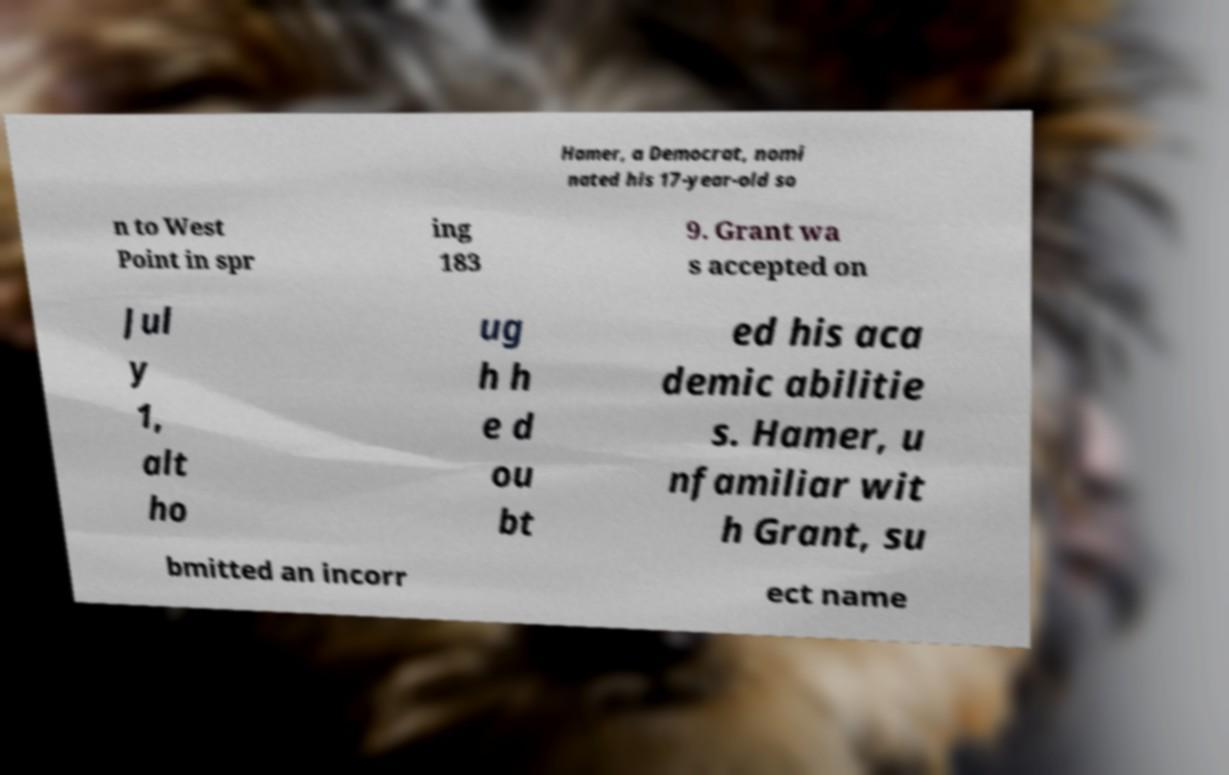Can you read and provide the text displayed in the image?This photo seems to have some interesting text. Can you extract and type it out for me? Hamer, a Democrat, nomi nated his 17-year-old so n to West Point in spr ing 183 9. Grant wa s accepted on Jul y 1, alt ho ug h h e d ou bt ed his aca demic abilitie s. Hamer, u nfamiliar wit h Grant, su bmitted an incorr ect name 